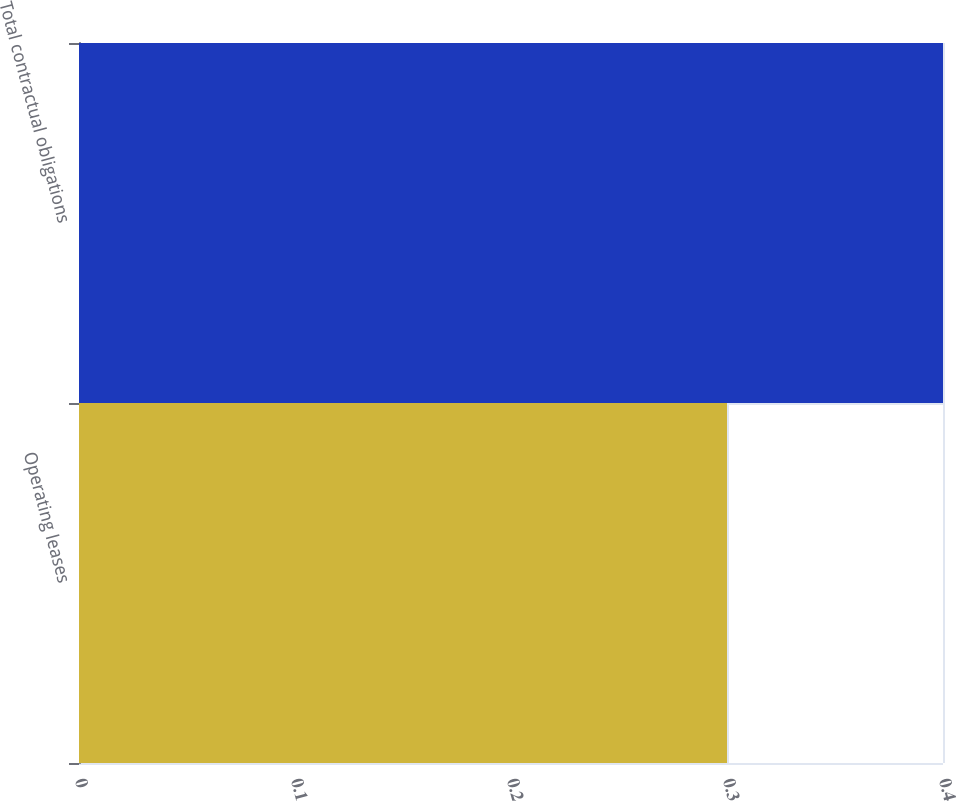<chart> <loc_0><loc_0><loc_500><loc_500><bar_chart><fcel>Operating leases<fcel>Total contractual obligations<nl><fcel>0.3<fcel>0.4<nl></chart> 